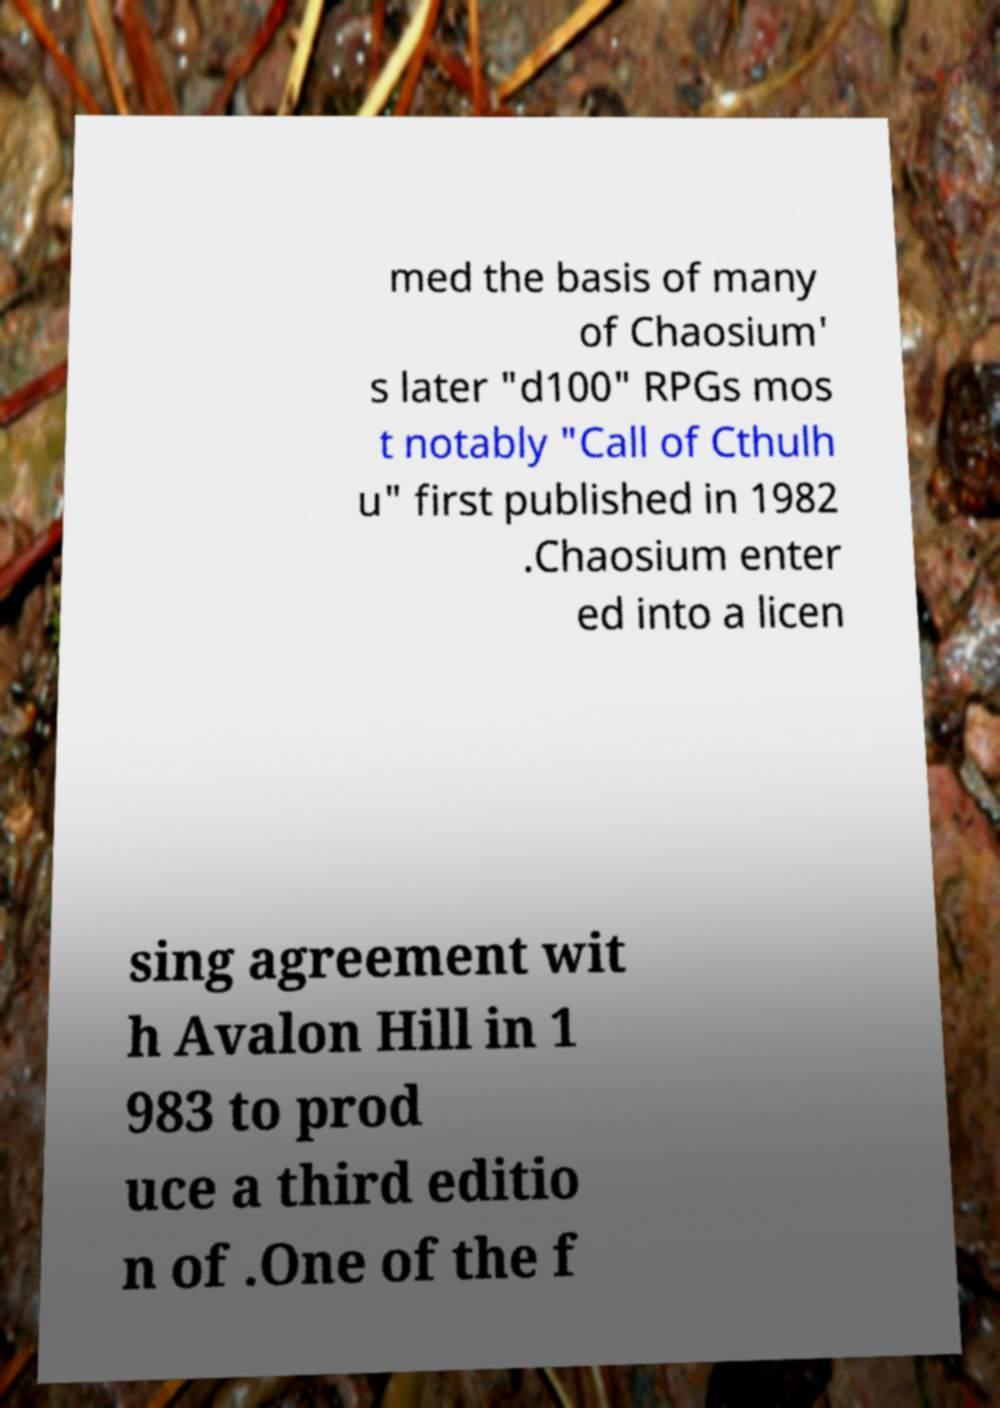Could you assist in decoding the text presented in this image and type it out clearly? med the basis of many of Chaosium' s later "d100" RPGs mos t notably "Call of Cthulh u" first published in 1982 .Chaosium enter ed into a licen sing agreement wit h Avalon Hill in 1 983 to prod uce a third editio n of .One of the f 